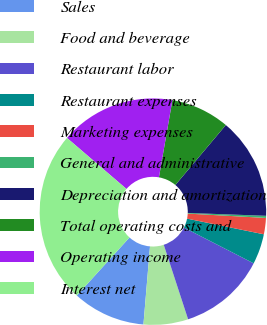Convert chart to OTSL. <chart><loc_0><loc_0><loc_500><loc_500><pie_chart><fcel>Sales<fcel>Food and beverage<fcel>Restaurant labor<fcel>Restaurant expenses<fcel>Marketing expenses<fcel>General and administrative<fcel>Depreciation and amortization<fcel>Total operating costs and<fcel>Operating income<fcel>Interest net<nl><fcel>10.4%<fcel>6.36%<fcel>12.43%<fcel>4.34%<fcel>2.32%<fcel>0.3%<fcel>14.45%<fcel>8.38%<fcel>16.47%<fcel>24.55%<nl></chart> 